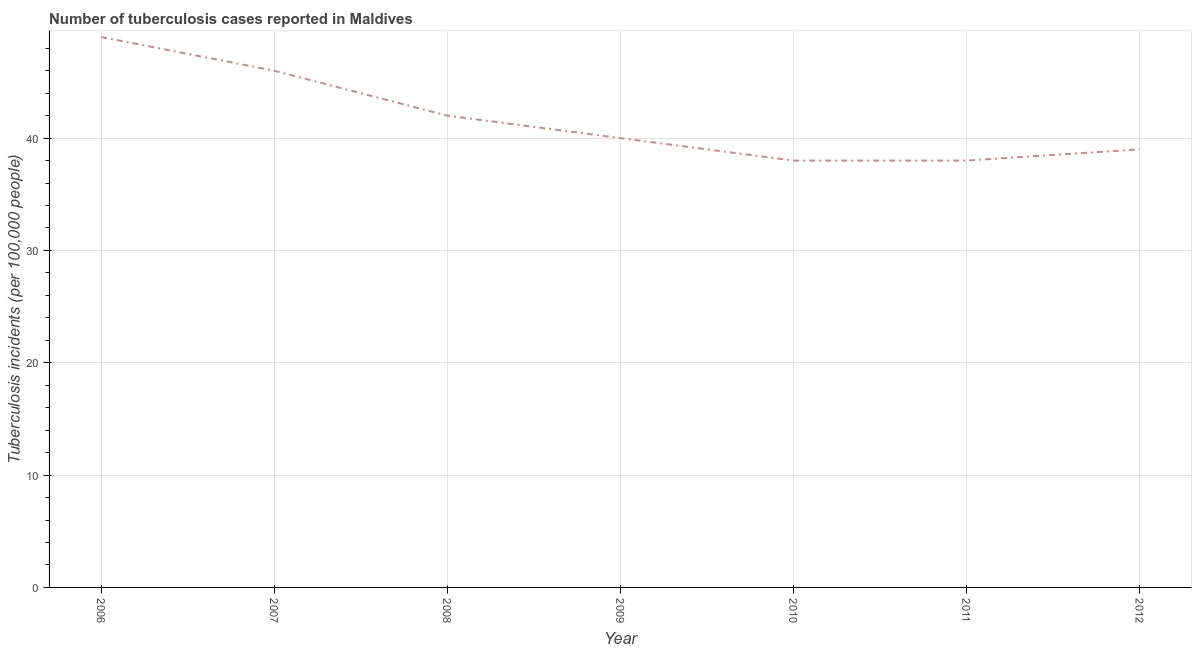What is the number of tuberculosis incidents in 2010?
Ensure brevity in your answer.  38. Across all years, what is the maximum number of tuberculosis incidents?
Your response must be concise. 49. Across all years, what is the minimum number of tuberculosis incidents?
Offer a terse response. 38. In which year was the number of tuberculosis incidents minimum?
Your answer should be very brief. 2010. What is the sum of the number of tuberculosis incidents?
Your answer should be compact. 292. What is the difference between the number of tuberculosis incidents in 2008 and 2010?
Provide a short and direct response. 4. What is the average number of tuberculosis incidents per year?
Offer a terse response. 41.71. What is the median number of tuberculosis incidents?
Offer a terse response. 40. In how many years, is the number of tuberculosis incidents greater than 44 ?
Your answer should be compact. 2. Do a majority of the years between 2010 and 2006 (inclusive) have number of tuberculosis incidents greater than 22 ?
Your answer should be compact. Yes. What is the ratio of the number of tuberculosis incidents in 2007 to that in 2008?
Provide a short and direct response. 1.1. What is the difference between the highest and the second highest number of tuberculosis incidents?
Your response must be concise. 3. Is the sum of the number of tuberculosis incidents in 2009 and 2012 greater than the maximum number of tuberculosis incidents across all years?
Ensure brevity in your answer.  Yes. What is the difference between the highest and the lowest number of tuberculosis incidents?
Offer a very short reply. 11. How many lines are there?
Give a very brief answer. 1. What is the difference between two consecutive major ticks on the Y-axis?
Make the answer very short. 10. Are the values on the major ticks of Y-axis written in scientific E-notation?
Make the answer very short. No. Does the graph contain any zero values?
Make the answer very short. No. Does the graph contain grids?
Give a very brief answer. Yes. What is the title of the graph?
Ensure brevity in your answer.  Number of tuberculosis cases reported in Maldives. What is the label or title of the X-axis?
Keep it short and to the point. Year. What is the label or title of the Y-axis?
Give a very brief answer. Tuberculosis incidents (per 100,0 people). What is the Tuberculosis incidents (per 100,000 people) in 2006?
Your response must be concise. 49. What is the Tuberculosis incidents (per 100,000 people) in 2010?
Make the answer very short. 38. What is the Tuberculosis incidents (per 100,000 people) in 2012?
Give a very brief answer. 39. What is the difference between the Tuberculosis incidents (per 100,000 people) in 2006 and 2008?
Offer a terse response. 7. What is the difference between the Tuberculosis incidents (per 100,000 people) in 2006 and 2010?
Offer a very short reply. 11. What is the difference between the Tuberculosis incidents (per 100,000 people) in 2007 and 2008?
Provide a short and direct response. 4. What is the difference between the Tuberculosis incidents (per 100,000 people) in 2007 and 2011?
Your answer should be very brief. 8. What is the difference between the Tuberculosis incidents (per 100,000 people) in 2008 and 2009?
Offer a terse response. 2. What is the difference between the Tuberculosis incidents (per 100,000 people) in 2008 and 2011?
Provide a short and direct response. 4. What is the difference between the Tuberculosis incidents (per 100,000 people) in 2010 and 2011?
Provide a succinct answer. 0. What is the ratio of the Tuberculosis incidents (per 100,000 people) in 2006 to that in 2007?
Offer a terse response. 1.06. What is the ratio of the Tuberculosis incidents (per 100,000 people) in 2006 to that in 2008?
Provide a succinct answer. 1.17. What is the ratio of the Tuberculosis incidents (per 100,000 people) in 2006 to that in 2009?
Ensure brevity in your answer.  1.23. What is the ratio of the Tuberculosis incidents (per 100,000 people) in 2006 to that in 2010?
Provide a short and direct response. 1.29. What is the ratio of the Tuberculosis incidents (per 100,000 people) in 2006 to that in 2011?
Offer a terse response. 1.29. What is the ratio of the Tuberculosis incidents (per 100,000 people) in 2006 to that in 2012?
Provide a succinct answer. 1.26. What is the ratio of the Tuberculosis incidents (per 100,000 people) in 2007 to that in 2008?
Your response must be concise. 1.09. What is the ratio of the Tuberculosis incidents (per 100,000 people) in 2007 to that in 2009?
Your answer should be compact. 1.15. What is the ratio of the Tuberculosis incidents (per 100,000 people) in 2007 to that in 2010?
Offer a very short reply. 1.21. What is the ratio of the Tuberculosis incidents (per 100,000 people) in 2007 to that in 2011?
Offer a terse response. 1.21. What is the ratio of the Tuberculosis incidents (per 100,000 people) in 2007 to that in 2012?
Give a very brief answer. 1.18. What is the ratio of the Tuberculosis incidents (per 100,000 people) in 2008 to that in 2010?
Make the answer very short. 1.1. What is the ratio of the Tuberculosis incidents (per 100,000 people) in 2008 to that in 2011?
Give a very brief answer. 1.1. What is the ratio of the Tuberculosis incidents (per 100,000 people) in 2008 to that in 2012?
Your answer should be compact. 1.08. What is the ratio of the Tuberculosis incidents (per 100,000 people) in 2009 to that in 2010?
Your answer should be very brief. 1.05. What is the ratio of the Tuberculosis incidents (per 100,000 people) in 2009 to that in 2011?
Provide a short and direct response. 1.05. What is the ratio of the Tuberculosis incidents (per 100,000 people) in 2010 to that in 2011?
Keep it short and to the point. 1. What is the ratio of the Tuberculosis incidents (per 100,000 people) in 2010 to that in 2012?
Keep it short and to the point. 0.97. 